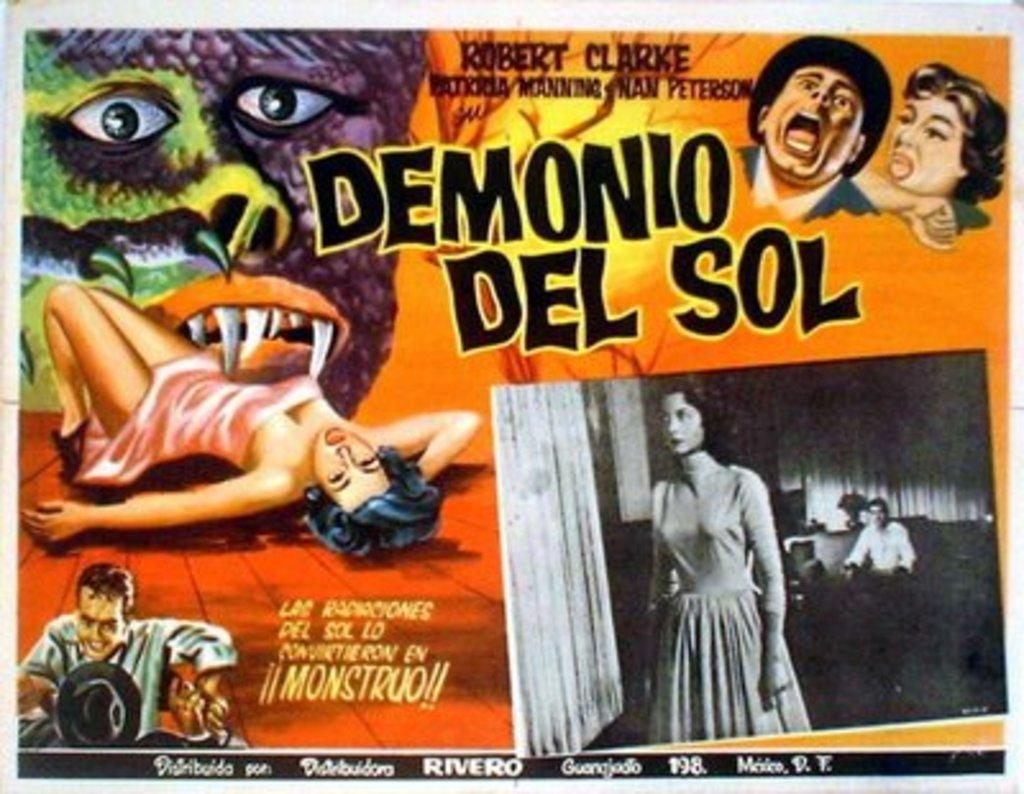Provide a one-sentence caption for the provided image. The movie poster for Demonio del Sol has a creature with fangs biting a woman. 